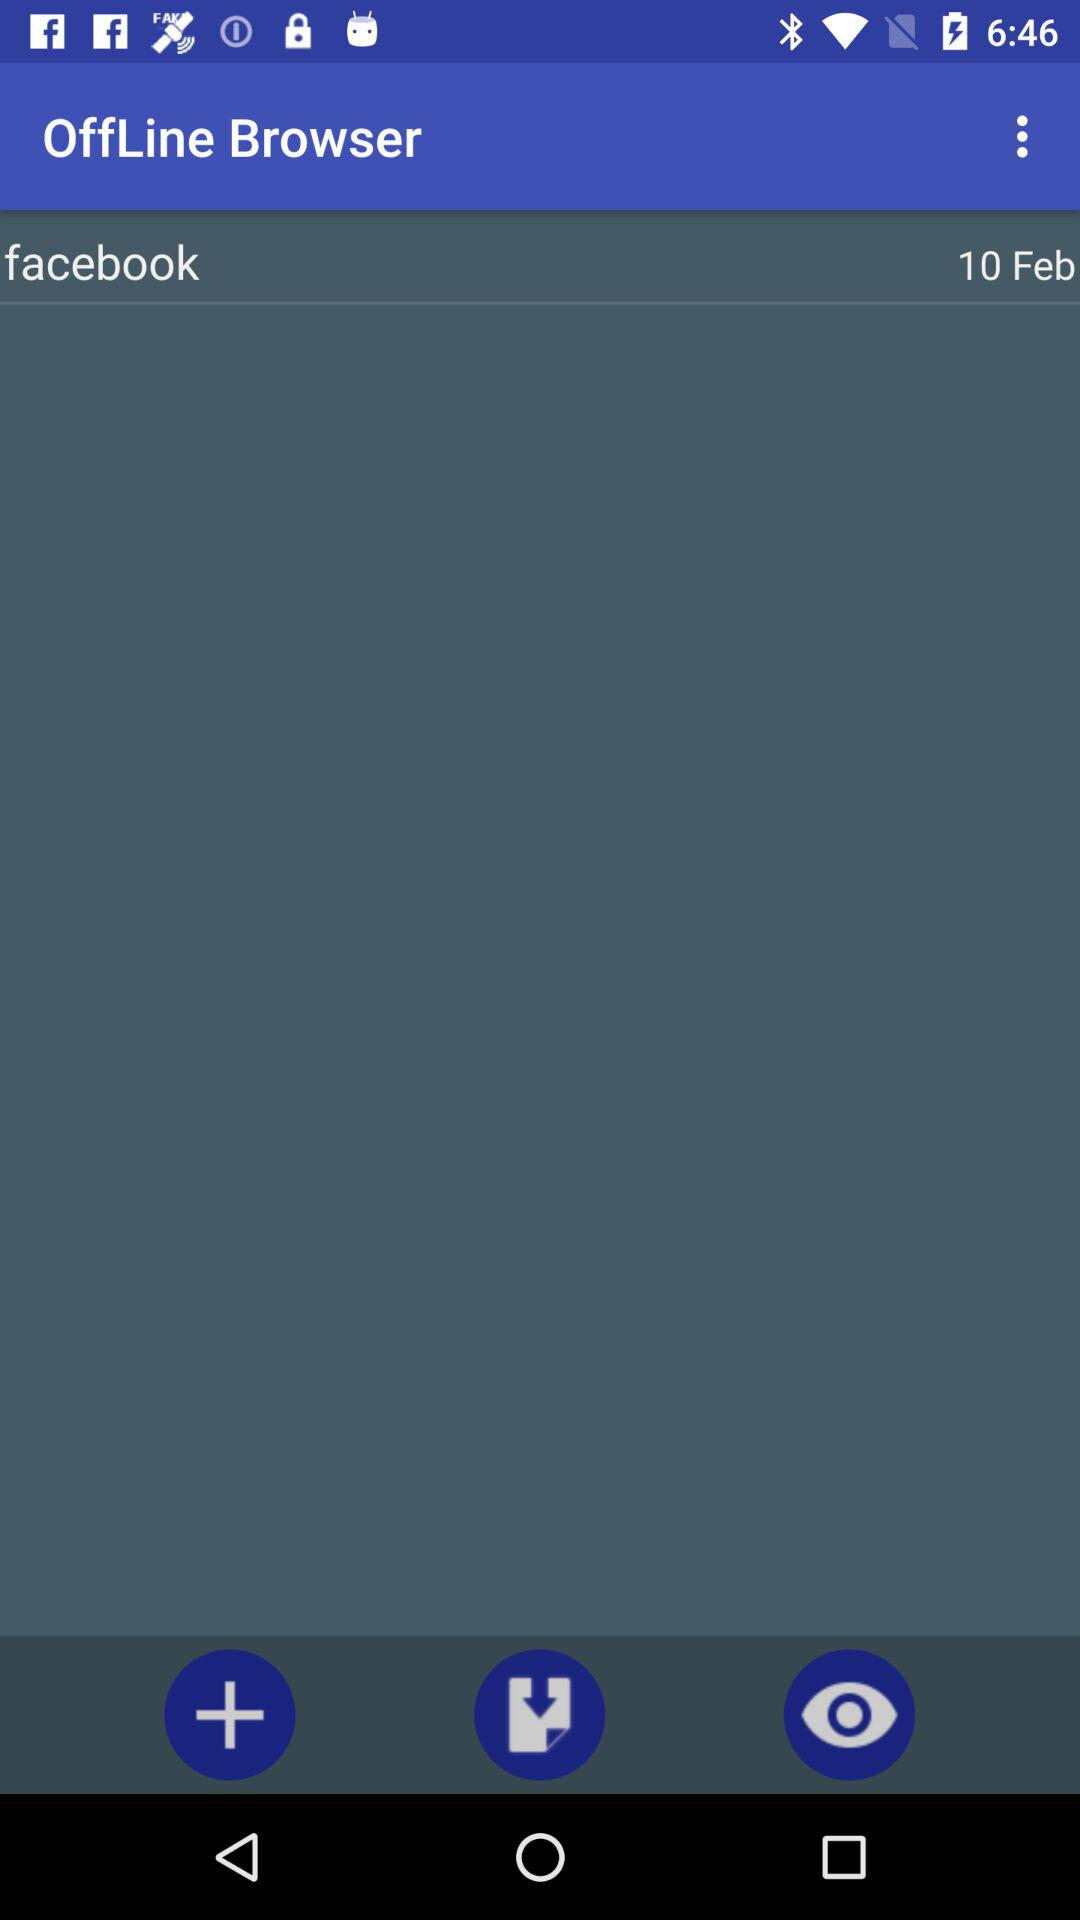What is the name of the application? The name of the application is "OffLine Browser". 